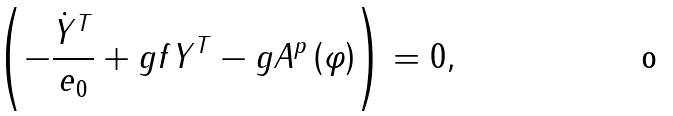<formula> <loc_0><loc_0><loc_500><loc_500>\left ( - \frac { \dot { Y } ^ { T } } { e _ { 0 } } + g f Y ^ { T } - g A ^ { p } \left ( \varphi \right ) \right ) = 0 ,</formula> 